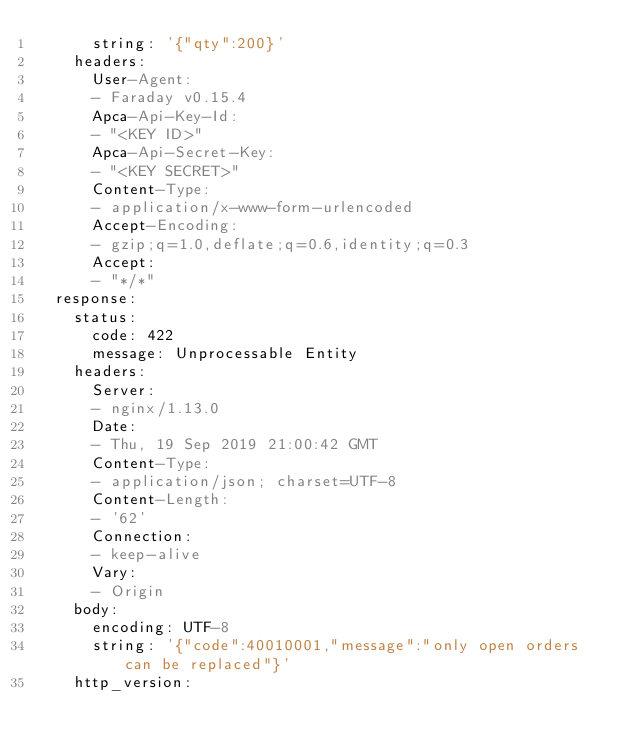<code> <loc_0><loc_0><loc_500><loc_500><_YAML_>      string: '{"qty":200}'
    headers:
      User-Agent:
      - Faraday v0.15.4
      Apca-Api-Key-Id:
      - "<KEY ID>"
      Apca-Api-Secret-Key:
      - "<KEY SECRET>"
      Content-Type:
      - application/x-www-form-urlencoded
      Accept-Encoding:
      - gzip;q=1.0,deflate;q=0.6,identity;q=0.3
      Accept:
      - "*/*"
  response:
    status:
      code: 422
      message: Unprocessable Entity
    headers:
      Server:
      - nginx/1.13.0
      Date:
      - Thu, 19 Sep 2019 21:00:42 GMT
      Content-Type:
      - application/json; charset=UTF-8
      Content-Length:
      - '62'
      Connection:
      - keep-alive
      Vary:
      - Origin
    body:
      encoding: UTF-8
      string: '{"code":40010001,"message":"only open orders can be replaced"}'
    http_version: </code> 